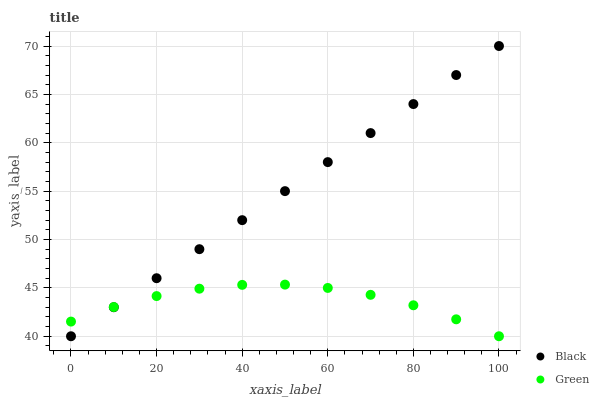Does Green have the minimum area under the curve?
Answer yes or no. Yes. Does Black have the maximum area under the curve?
Answer yes or no. Yes. Does Black have the minimum area under the curve?
Answer yes or no. No. Is Black the smoothest?
Answer yes or no. Yes. Is Green the roughest?
Answer yes or no. Yes. Is Black the roughest?
Answer yes or no. No. Does Green have the lowest value?
Answer yes or no. Yes. Does Black have the highest value?
Answer yes or no. Yes. Does Black intersect Green?
Answer yes or no. Yes. Is Black less than Green?
Answer yes or no. No. Is Black greater than Green?
Answer yes or no. No. 